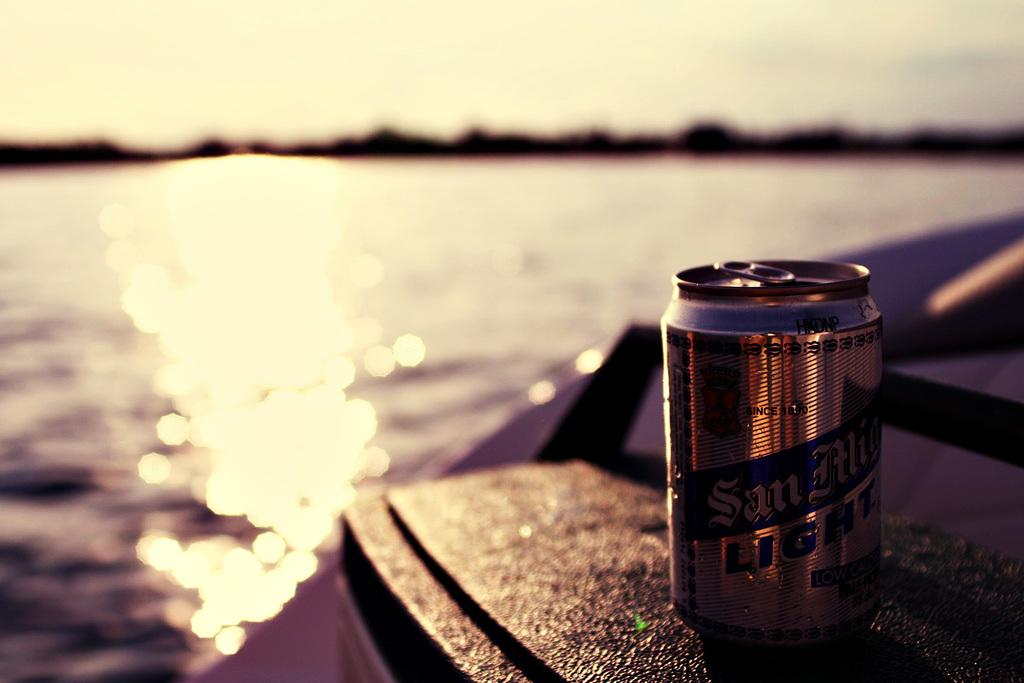<image>
Write a terse but informative summary of the picture. A can of San MIguel beer sitting on top of a cooler. 